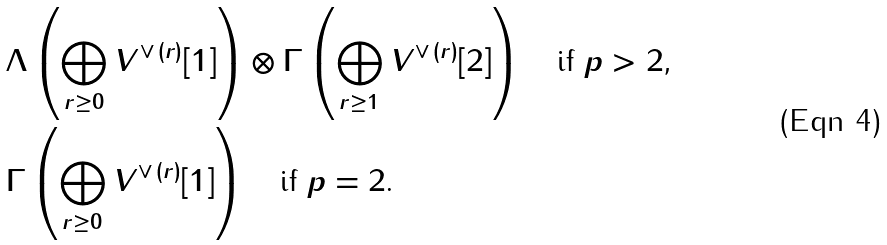<formula> <loc_0><loc_0><loc_500><loc_500>& \Lambda \left ( \bigoplus _ { r \geq 0 } V ^ { \vee \, ( r ) } [ 1 ] \right ) \otimes \Gamma \left ( \bigoplus _ { r \geq 1 } V ^ { \vee \, ( r ) } [ 2 ] \right ) \quad \text {if $p>2$,} \\ & \Gamma \left ( \bigoplus _ { r \geq 0 } V ^ { \vee \, ( r ) } [ 1 ] \right ) \quad \text {if $p=2$.}</formula> 